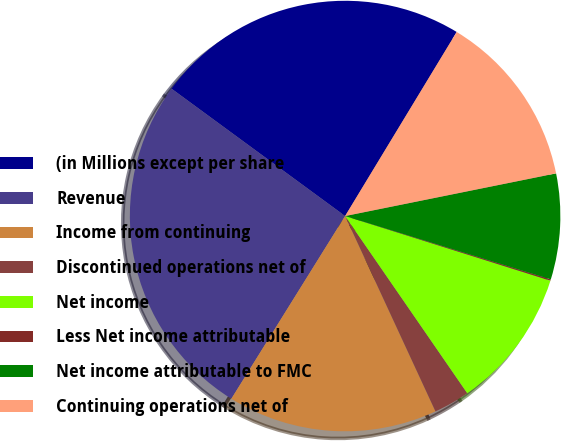<chart> <loc_0><loc_0><loc_500><loc_500><pie_chart><fcel>(in Millions except per share<fcel>Revenue<fcel>Income from continuing<fcel>Discontinued operations net of<fcel>Net income<fcel>Less Net income attributable<fcel>Net income attributable to FMC<fcel>Continuing operations net of<nl><fcel>23.6%<fcel>26.21%<fcel>15.76%<fcel>2.71%<fcel>10.54%<fcel>0.1%<fcel>7.93%<fcel>13.15%<nl></chart> 